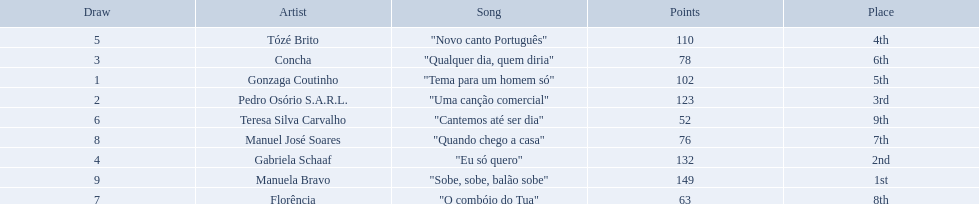Is there a song called eu so quero in the table? "Eu só quero". Who sang that song? Gabriela Schaaf. 